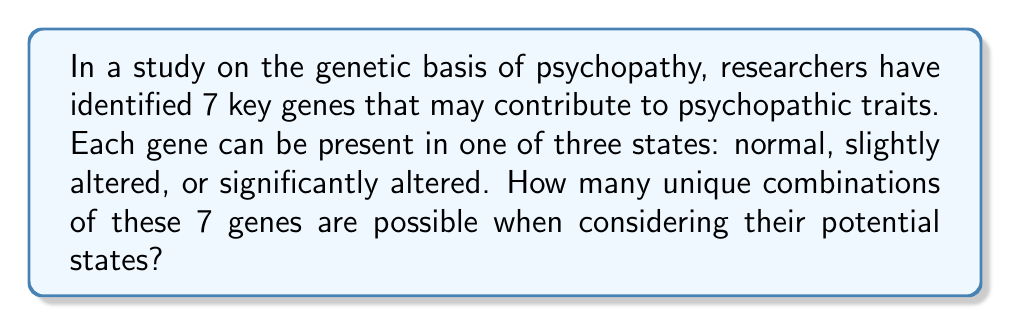Show me your answer to this math problem. Let's approach this step-by-step:

1) We have 7 genes, each with 3 possible states.

2) This scenario can be modeled as a combination problem where we're selecting one state for each gene.

3) For each gene, we have 3 independent choices.

4) According to the multiplication principle, when we have independent choices, we multiply the number of possibilities for each choice.

5) Therefore, the total number of combinations is:

   $$3 \times 3 \times 3 \times 3 \times 3 \times 3 \times 3$$

6) This can be written more concisely as:

   $$3^7$$

7) Calculating this:

   $$3^7 = 3 \times 3 \times 3 \times 3 \times 3 \times 3 \times 3 = 2187$$

Thus, there are 2187 unique combinations of these 7 genes when considering their potential states.
Answer: 2187 